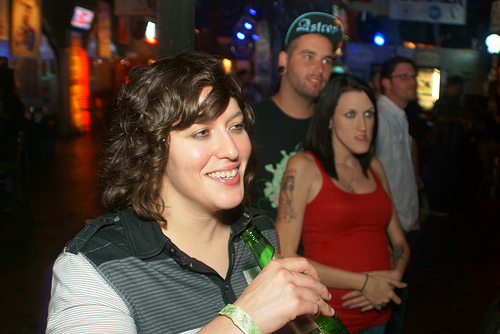<image>
Is there a lady in front of the man? Yes. The lady is positioned in front of the man, appearing closer to the camera viewpoint. Is the man above the woman? No. The man is not positioned above the woman. The vertical arrangement shows a different relationship. 